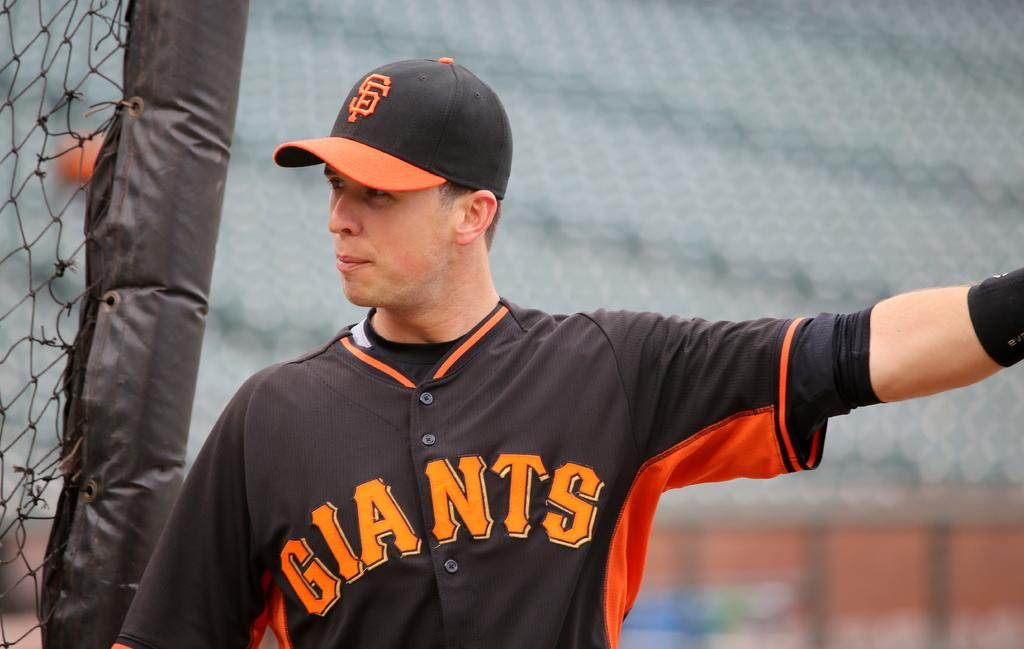<image>
Offer a succinct explanation of the picture presented. A baseball player with a brown and ornage top with GIANTS on the front points to somewhere on the field. 